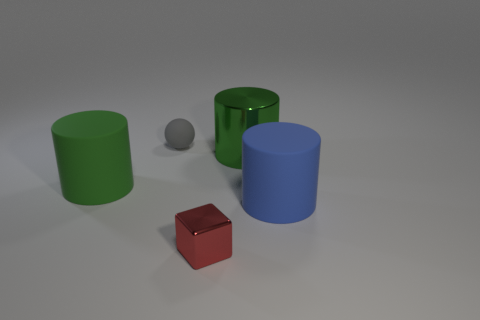Add 3 big green things. How many objects exist? 8 Subtract all balls. How many objects are left? 4 Subtract 0 gray cylinders. How many objects are left? 5 Subtract all tiny things. Subtract all green metal objects. How many objects are left? 2 Add 4 green metallic cylinders. How many green metallic cylinders are left? 5 Add 3 large things. How many large things exist? 6 